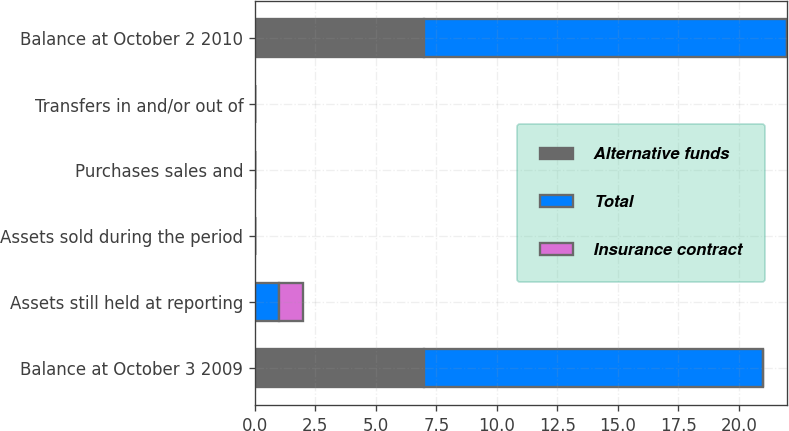<chart> <loc_0><loc_0><loc_500><loc_500><stacked_bar_chart><ecel><fcel>Balance at October 3 2009<fcel>Assets still held at reporting<fcel>Assets sold during the period<fcel>Purchases sales and<fcel>Transfers in and/or out of<fcel>Balance at October 2 2010<nl><fcel>Alternative funds<fcel>7<fcel>0<fcel>0<fcel>0<fcel>0<fcel>7<nl><fcel>Total<fcel>14<fcel>1<fcel>0<fcel>0<fcel>0<fcel>15<nl><fcel>Insurance contract<fcel>0<fcel>1<fcel>0<fcel>0<fcel>0<fcel>0<nl></chart> 